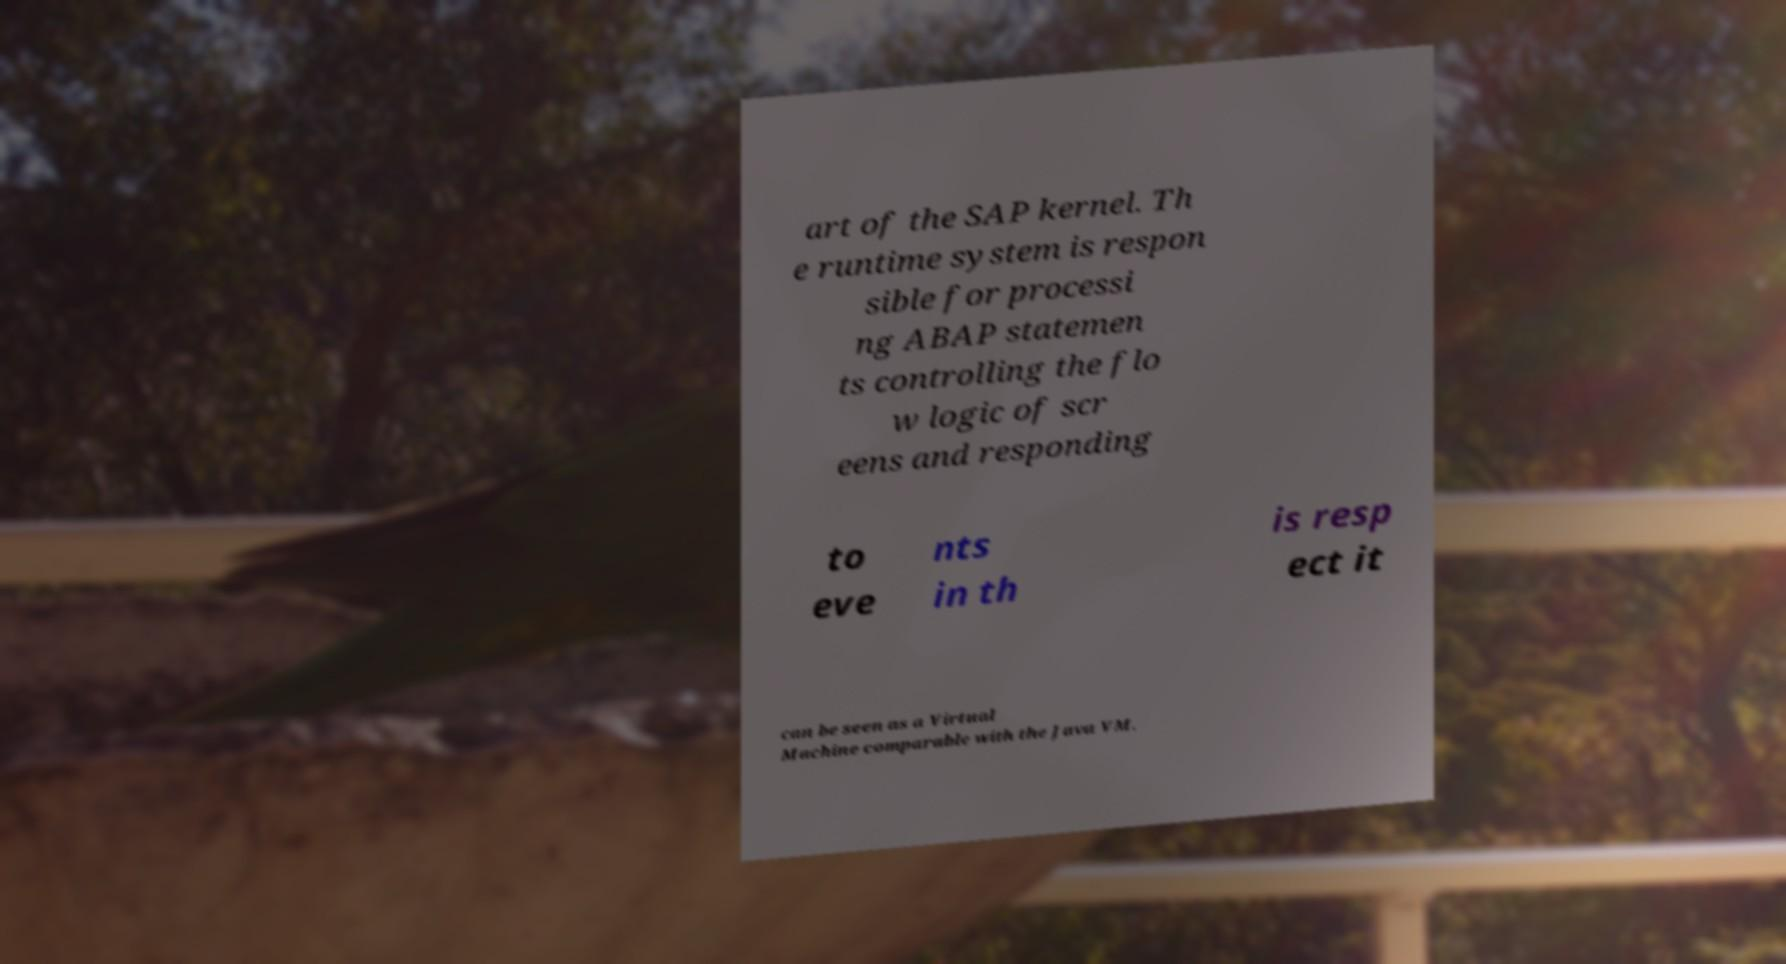Please identify and transcribe the text found in this image. art of the SAP kernel. Th e runtime system is respon sible for processi ng ABAP statemen ts controlling the flo w logic of scr eens and responding to eve nts in th is resp ect it can be seen as a Virtual Machine comparable with the Java VM. 